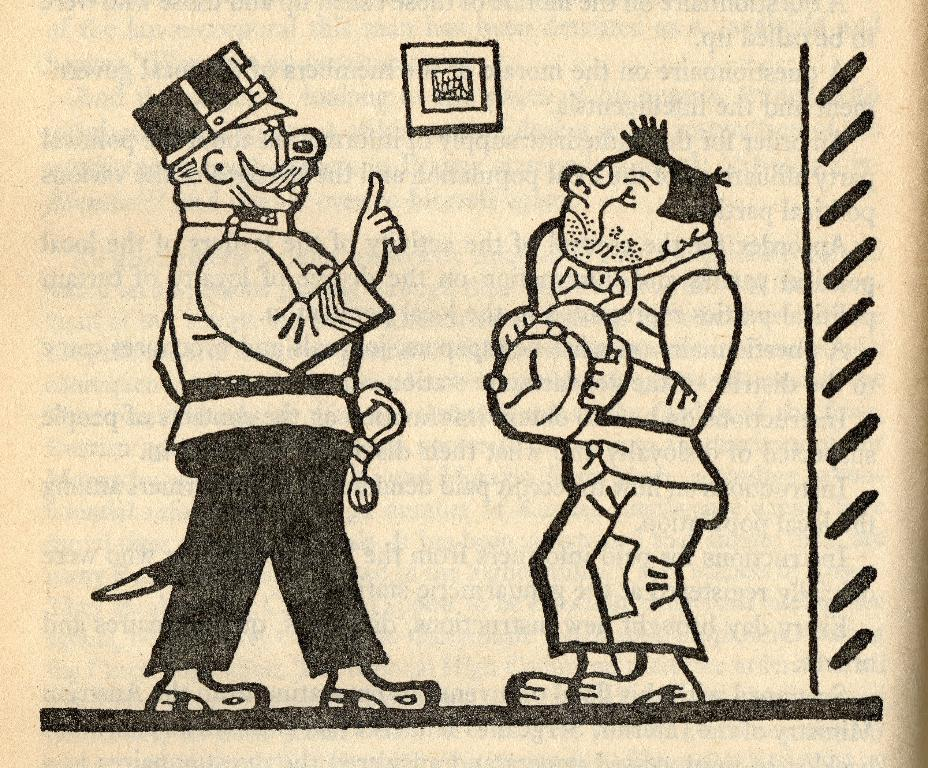What is the color of the page in the image? The page in the image is white-colored. What type of content is on the page? There are cartoons on the page. What color scheme do the cartoons have? The cartoons have a white and black color scheme. What type of coat is being offered by the cartoon character in the image? There is no cartoon character offering a coat in the image; the cartoons have a white and black color scheme. What does the cartoon character's tongue look like in the image? There is no cartoon character with a visible tongue in the image; the cartoons are in a white and black color scheme. 